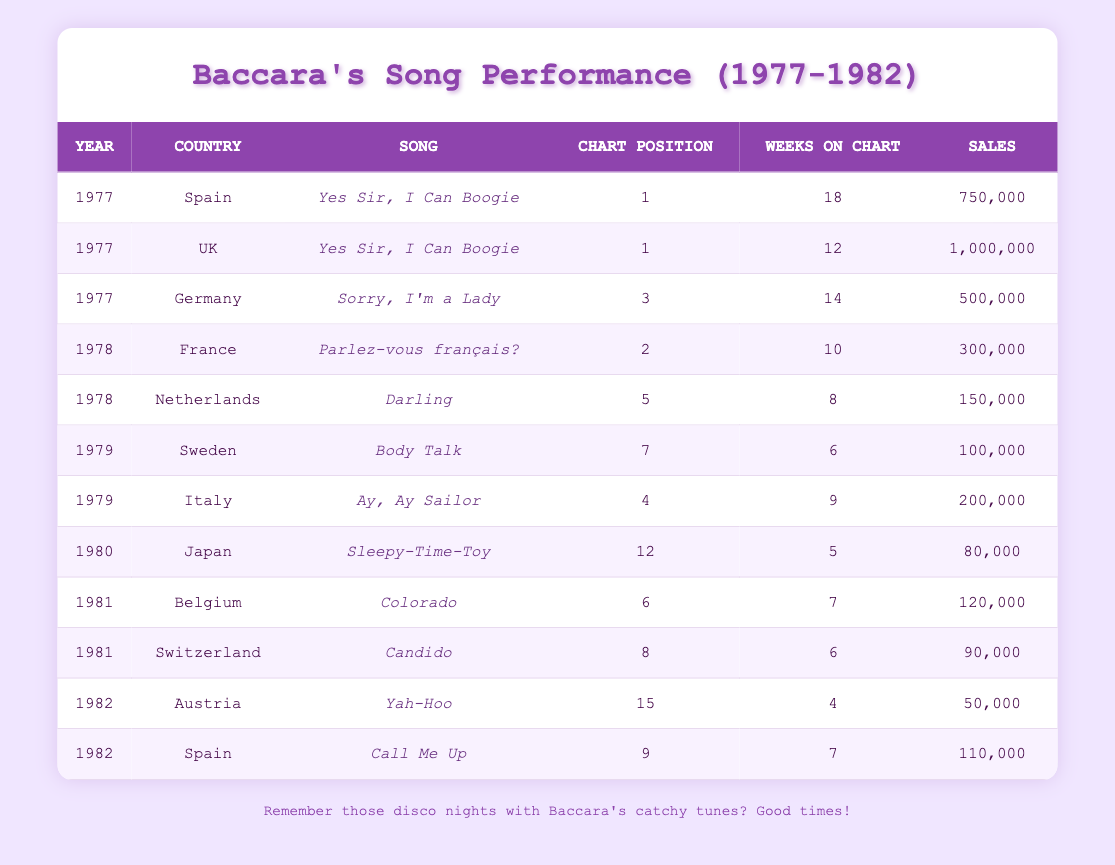What song had the highest chart position in 1977? In 1977, "Yes Sir, I Can Boogie" was ranked 1st in both Spain and the UK. This is the highest chart position recorded in that year on the table.
Answer: Yes Sir, I Can Boogie Which country did Baccara achieve the highest sales? Looking at the sales data, the UK had the highest sales of "Yes Sir, I Can Boogie" with 1,000,000 units sold, which is more than any other country in the table.
Answer: UK What is the total number of weeks Baccara's songs spent on the chart in 1978? In 1978, the sum of weeks on chart are: 10 (France) + 8 (Netherlands) = 18 weeks total.
Answer: 18 weeks Did Baccara have a song in the top 10 in 1982? Reviewing 1982’s data shows that "Call Me Up" achieved a chart position of 9, which is in the top 10.
Answer: Yes Which song had the lowest sales across all the years? The song "Yah-Hoo" from Austria in 1982 had the lowest sales with 50,000 units sold, which is less than any other song listed in the data.
Answer: Yah-Hoo What was the average chart position of Baccara's songs in 1981? In 1981, Baccara's songs "Colorado" (6) and "Candido" (8) had a combined average chart position of (6 + 8) / 2 = 7.
Answer: 7 How many different songs did Baccara release in 1979? The data shows two songs released in 1979: "Body Talk" and "Ay, Ay Sailor," indicating two distinct titles in that year.
Answer: 2 Which country had the longest duration for a song on the chart? Analyzing the duration data, "Yes Sir, I Can Boogie" from Spain in 1977 spent the longest time on the chart, which was 18 weeks.
Answer: Spain What was the total sales for Baccara's songs in 1980? The only song listed in 1980 is "Sleepy-Time-Toy," which had sales of 80,000. Thus, total sales for that year are simply 80,000.
Answer: 80,000 